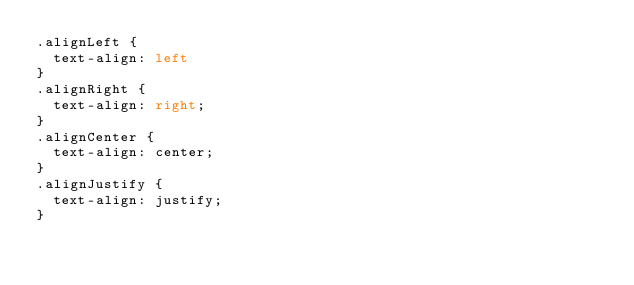Convert code to text. <code><loc_0><loc_0><loc_500><loc_500><_CSS_>.alignLeft {
	text-align: left
}
.alignRight {
	text-align: right;
}
.alignCenter {
	text-align: center;
}
.alignJustify {
	text-align: justify;
}</code> 